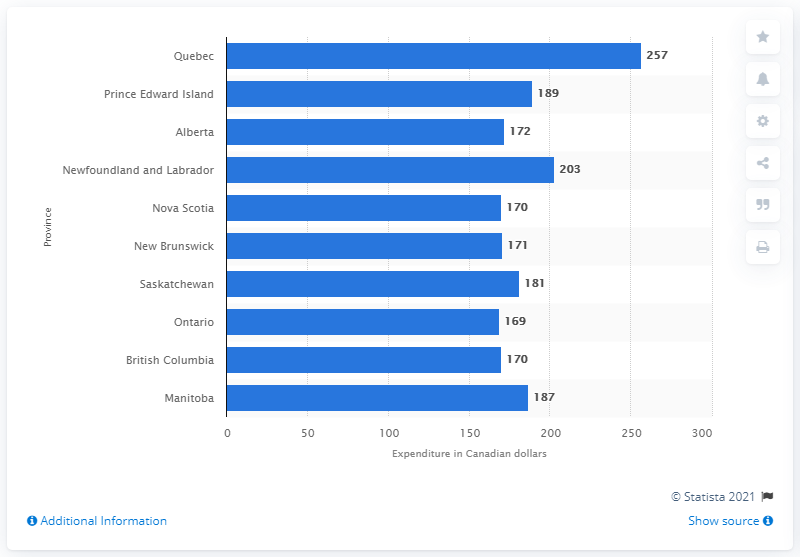Draw attention to some important aspects in this diagram. The average annual household expenditure on bread in British Columbia was 170 dollars in the year 2020. In Canada, Quebec had the highest average annual household expenditure on bread, according to data. In Quebec, the average annual household expenditure on bread was approximately 257 dollars. 